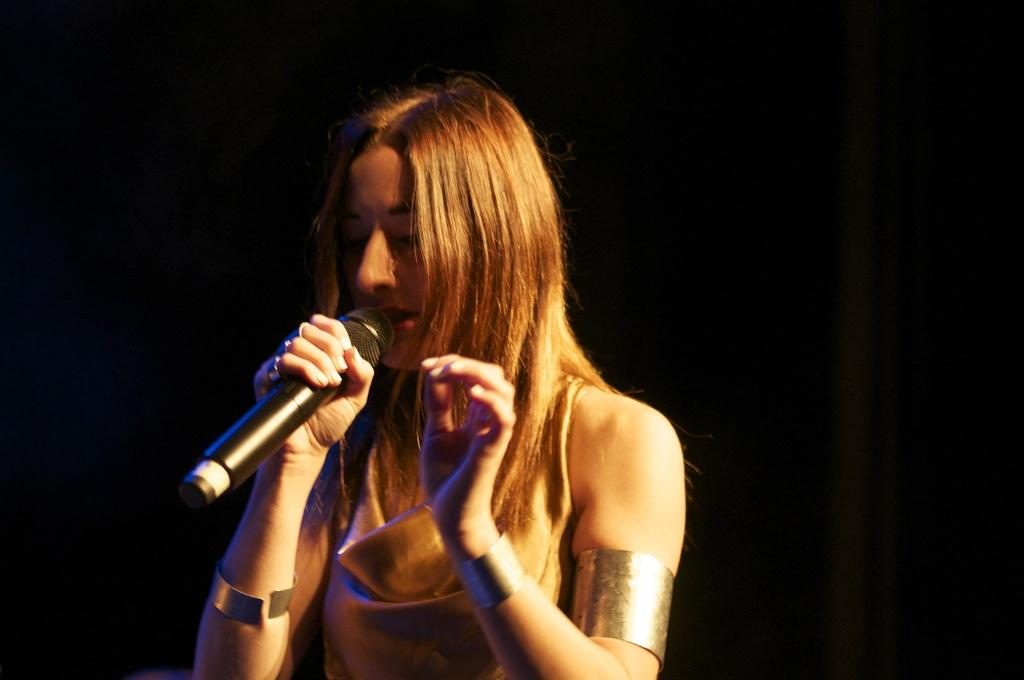Who is the main subject in the image? There is a woman in the image. What is the woman doing in the image? The woman is singing. What object is the woman holding in the image? The woman is holding a microphone. What type of badge is the woman wearing in the image? There is no badge visible in the image. How does the woman's sense of humor contribute to her performance in the image? The image does not provide any information about the woman's sense of humor or how it might contribute to her performance. 